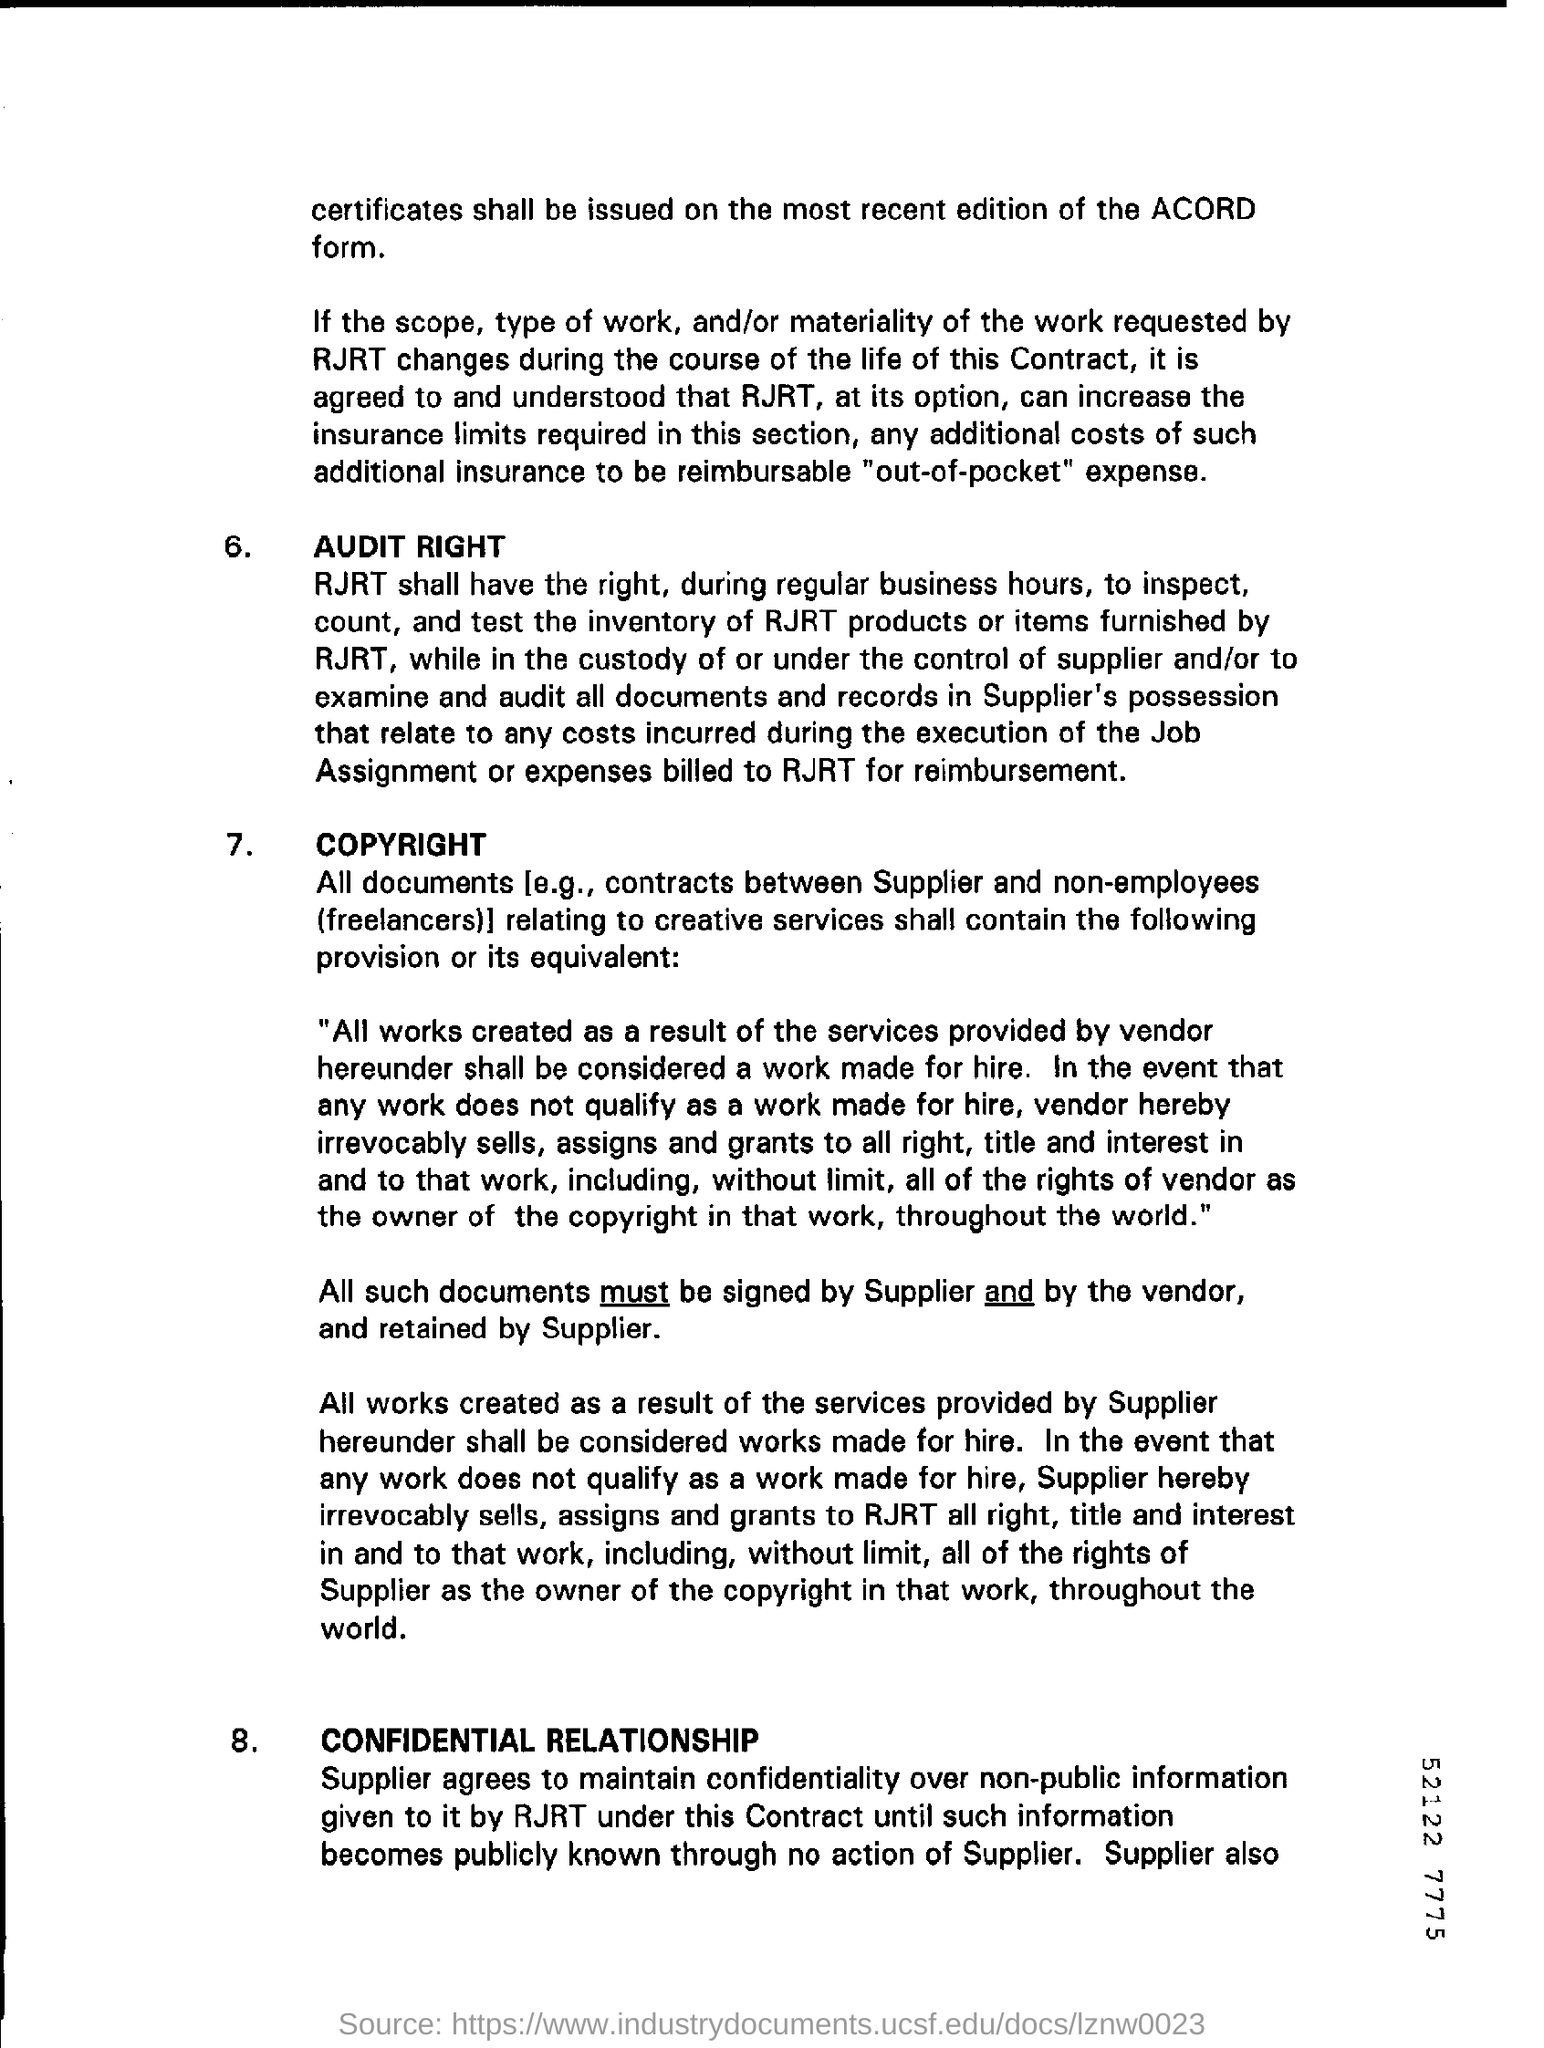What is the first title in the document?
Provide a succinct answer. Audit Right. 